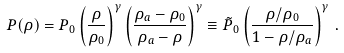<formula> <loc_0><loc_0><loc_500><loc_500>P ( \rho ) = P _ { 0 } \left ( \frac { \rho } { \rho _ { 0 } } \right ) ^ { \gamma } \left ( \frac { \rho _ { a } - \rho _ { 0 } } { \rho _ { a } - \rho } \right ) ^ { \gamma } \equiv \tilde { P } _ { 0 } \left ( \frac { \rho / \rho _ { 0 } } { 1 - \rho / \rho _ { a } } \right ) ^ { \gamma } \, .</formula> 